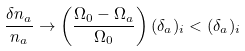Convert formula to latex. <formula><loc_0><loc_0><loc_500><loc_500>\frac { \delta n _ { a } } { n _ { a } } \rightarrow \left ( \frac { \Omega _ { 0 } - \Omega _ { a } } { \Omega _ { 0 } } \right ) ( \delta _ { a } ) _ { i } < ( \delta _ { a } ) _ { i }</formula> 